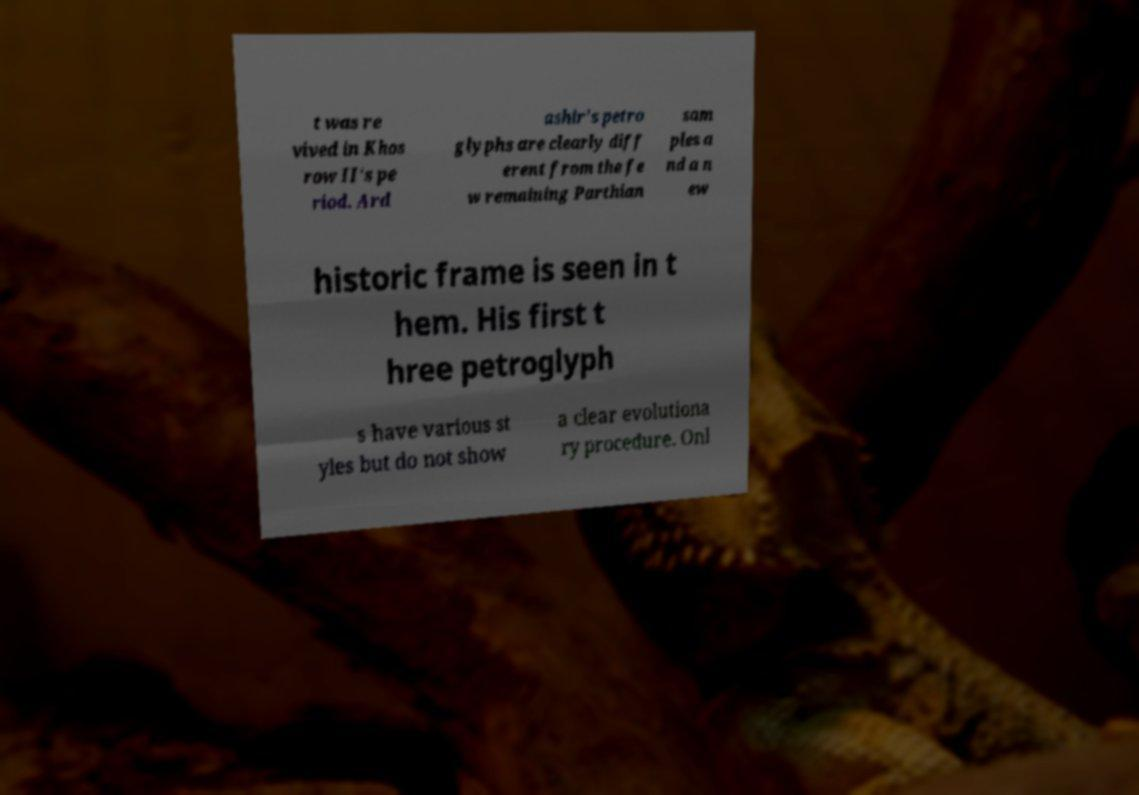For documentation purposes, I need the text within this image transcribed. Could you provide that? t was re vived in Khos row II's pe riod. Ard ashir's petro glyphs are clearly diff erent from the fe w remaining Parthian sam ples a nd a n ew historic frame is seen in t hem. His first t hree petroglyph s have various st yles but do not show a clear evolutiona ry procedure. Onl 